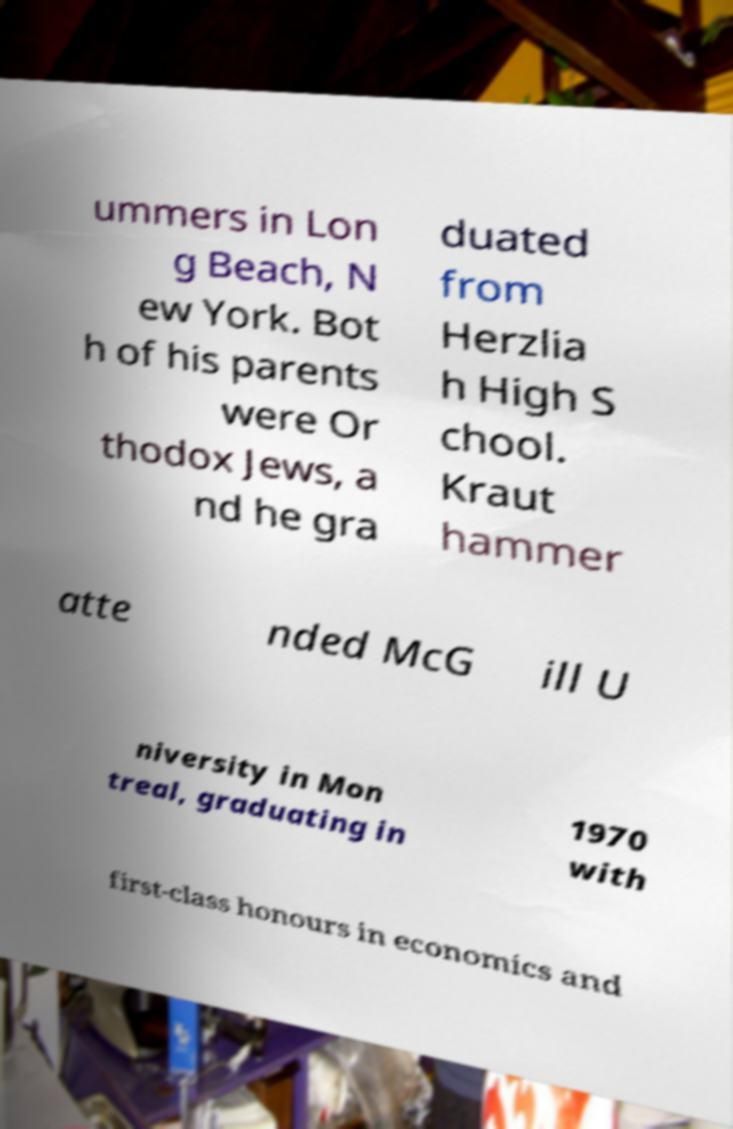Please identify and transcribe the text found in this image. ummers in Lon g Beach, N ew York. Bot h of his parents were Or thodox Jews, a nd he gra duated from Herzlia h High S chool. Kraut hammer atte nded McG ill U niversity in Mon treal, graduating in 1970 with first-class honours in economics and 